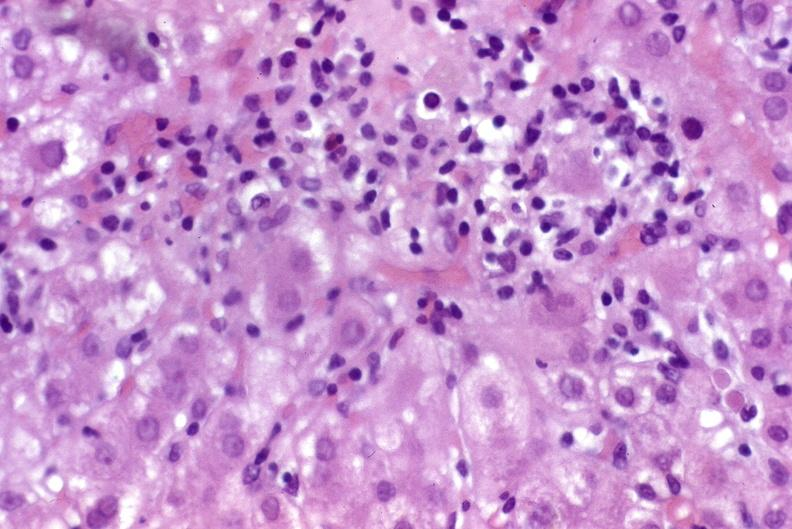does hilar cell tumor show recurrent hepatitis c virus?
Answer the question using a single word or phrase. No 